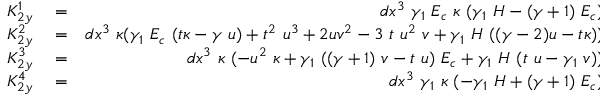Convert formula to latex. <formula><loc_0><loc_0><loc_500><loc_500>\begin{array} { r l r } { K _ { 2 y } ^ { 1 } } & = } & { d x ^ { 3 } \gamma _ { 1 } E _ { c } \kappa ( \gamma _ { 1 } H - ( \gamma + 1 ) E _ { c } ) } \\ { K _ { 2 y } ^ { 2 } } & = } & { d x ^ { 3 } \kappa ( \gamma _ { 1 } E _ { c } ( t \kappa - \gamma u ) + t ^ { 2 } u ^ { 3 } + 2 u v ^ { 2 } - 3 t u ^ { 2 } v + \gamma _ { 1 } H ( ( \gamma - 2 ) u - t \kappa ) ) } \\ { K _ { 2 y } ^ { 3 } } & = } & { d x ^ { 3 } \kappa ( - u ^ { 2 } \kappa + \gamma _ { 1 } ( ( \gamma + 1 ) v - t u ) E _ { c } + \gamma _ { 1 } H ( t u - \gamma _ { 1 } v ) ) } \\ { K _ { 2 y } ^ { 4 } } & = } & { d x ^ { 3 } \gamma _ { 1 } \kappa ( - \gamma _ { 1 } H + ( \gamma + 1 ) E _ { c } ) } \end{array}</formula> 